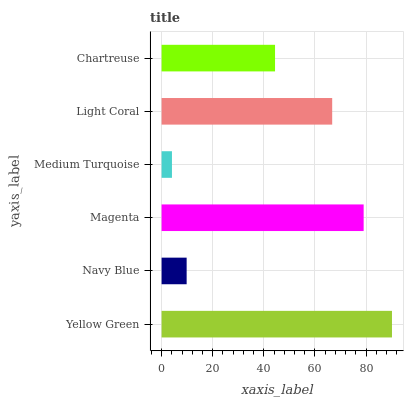Is Medium Turquoise the minimum?
Answer yes or no. Yes. Is Yellow Green the maximum?
Answer yes or no. Yes. Is Navy Blue the minimum?
Answer yes or no. No. Is Navy Blue the maximum?
Answer yes or no. No. Is Yellow Green greater than Navy Blue?
Answer yes or no. Yes. Is Navy Blue less than Yellow Green?
Answer yes or no. Yes. Is Navy Blue greater than Yellow Green?
Answer yes or no. No. Is Yellow Green less than Navy Blue?
Answer yes or no. No. Is Light Coral the high median?
Answer yes or no. Yes. Is Chartreuse the low median?
Answer yes or no. Yes. Is Chartreuse the high median?
Answer yes or no. No. Is Navy Blue the low median?
Answer yes or no. No. 